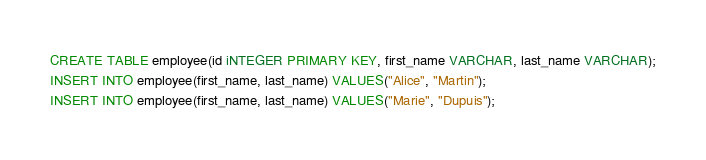Convert code to text. <code><loc_0><loc_0><loc_500><loc_500><_SQL_>CREATE TABLE employee(id iNTEGER PRIMARY KEY, first_name VARCHAR, last_name VARCHAR);
INSERT INTO employee(first_name, last_name) VALUES("Alice", "Martin");
INSERT INTO employee(first_name, last_name) VALUES("Marie", "Dupuis");
</code> 